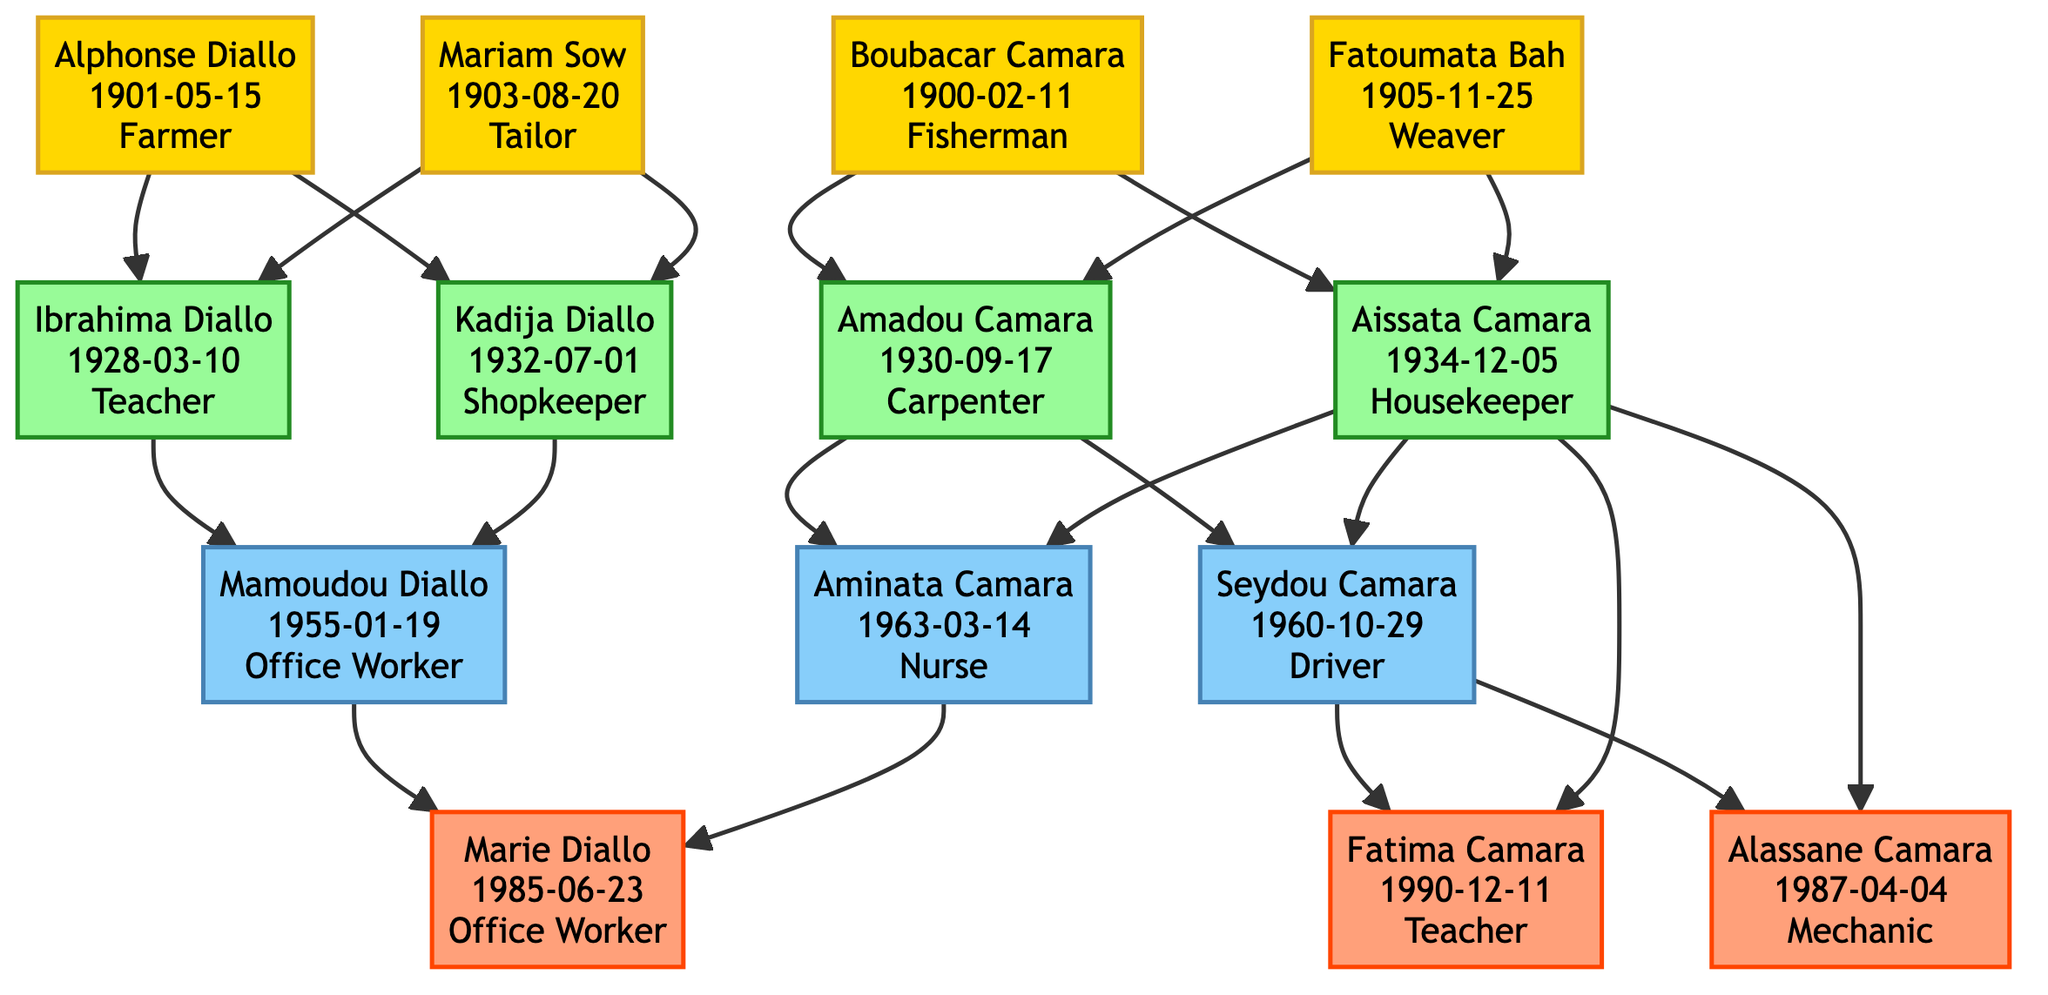what are the names of the great-grandparents? The great-grandparents are represented in the top layer of the diagram. They are Alphonse Diallo and Mariam Sow from one lineage, and Boubacar Camara and Fatoumata Bah from another.
Answer: Alphonse Diallo, Mariam Sow, Boubacar Camara, Fatoumata Bah how many grandparents are there? By counting the nodes in the grandparents' section of the diagram, there are four individuals: Ibrahima Diallo, Kadija Diallo, Amadou Camara, and Aissata Camara.
Answer: 4 who is the occupation of Mamoudou Diallo? Looking at the node for Mamoudou Diallo in the parents' section, he is listed as an Office Worker.
Answer: Office Worker which current generation member has a birthdate in 1990? In the current generation section, Fatima Camara has the birthdate listed as 1990-12-11.
Answer: Fatima Camara what is the relationship between Mamoudou Diallo and Marie Diallo? Marie Diallo is the child of Mamoudou Diallo, which can be traced from the diagram showing the connection between the parents' and current generation's nodes.
Answer: Father-Daughter how many individuals are shown in the current generation? By counting the nodes in the current generation section, there are three individuals: Marie Diallo, Fatima Camara, and Alassane Camara.
Answer: 3 which grandparent is a teacher? Ibrahima Diallo is in the grandparents' section and is listed as a Teacher.
Answer: Ibrahima Diallo who are the parents of Fatima Camara? By examining the connection in the diagram, Fatima Camara’s parents are Seydou Camara and Aissata Camara.
Answer: Seydou Camara, Aissata Camara who was born first among the great-grandparents? By comparing the birthdates in the great-grandparents' section, Alphonse Diallo born on 1901-05-15 is the first.
Answer: Alphonse Diallo 